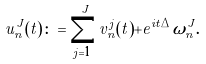Convert formula to latex. <formula><loc_0><loc_0><loc_500><loc_500>u _ { n } ^ { J } ( t ) \colon = \sum _ { j = 1 } ^ { J } v _ { n } ^ { j } ( t ) + e ^ { i t \Delta } \omega _ { n } ^ { J } .</formula> 